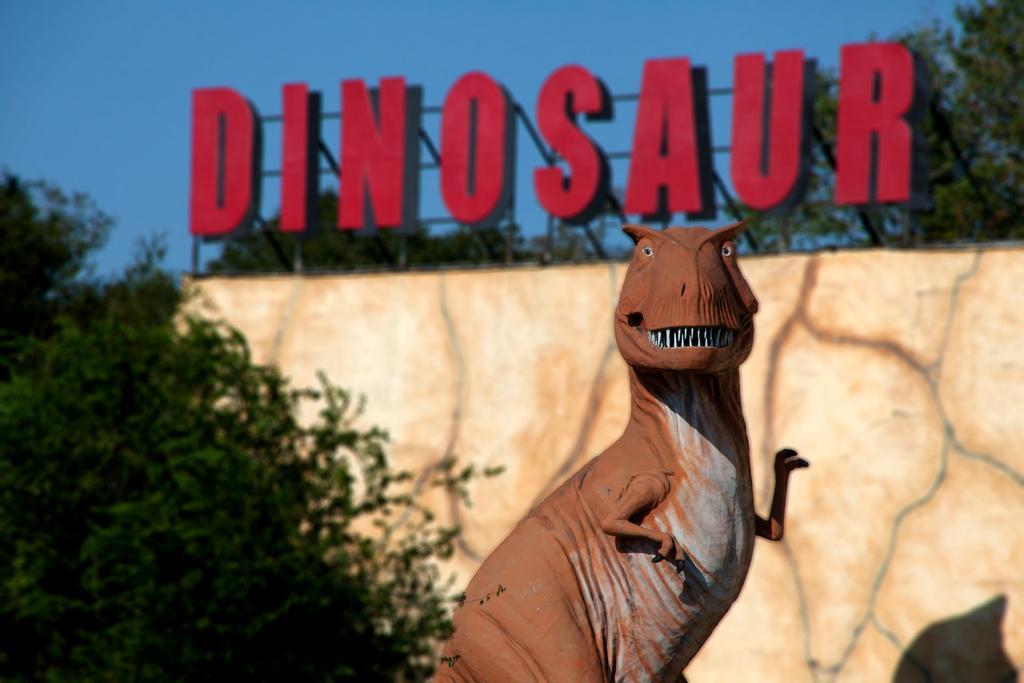Can you describe this image briefly? In this image I can see the statue of an animal and the animal is in brown color. Background I can see the board in red color, few trees in green color and the sky is in blue color. 